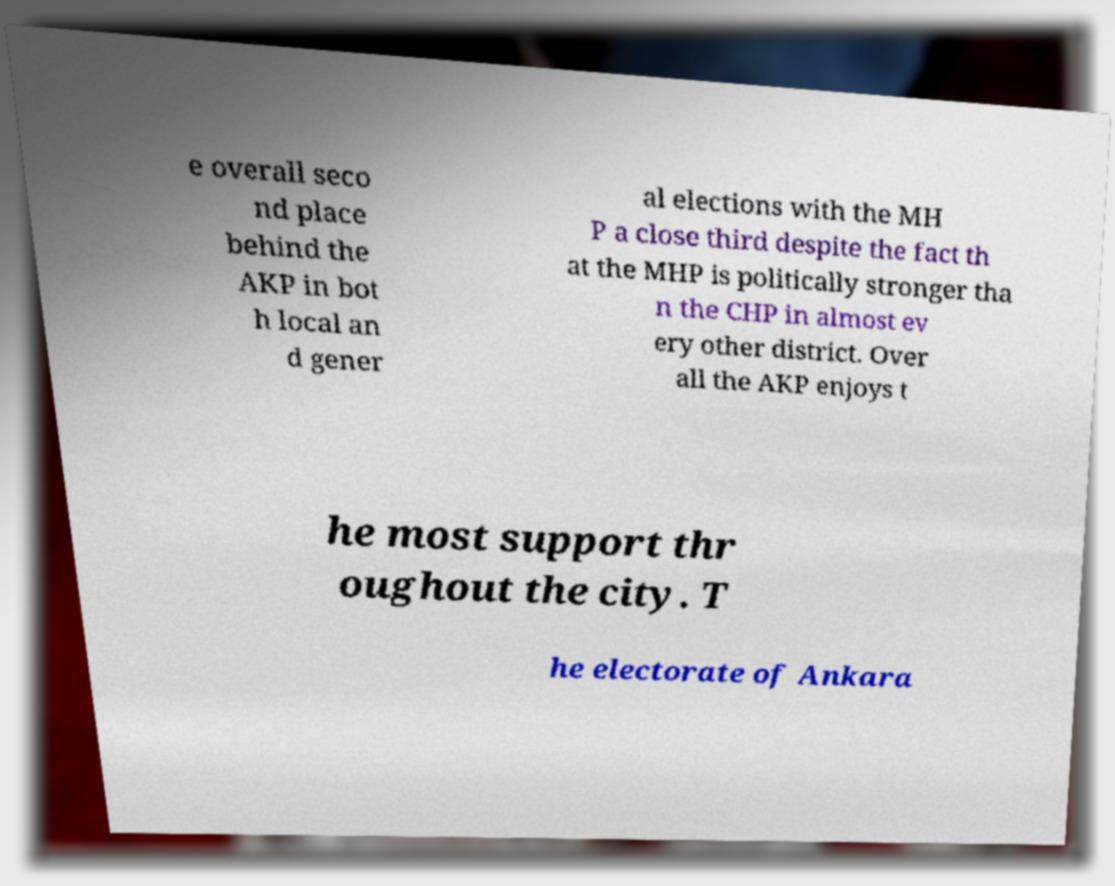There's text embedded in this image that I need extracted. Can you transcribe it verbatim? e overall seco nd place behind the AKP in bot h local an d gener al elections with the MH P a close third despite the fact th at the MHP is politically stronger tha n the CHP in almost ev ery other district. Over all the AKP enjoys t he most support thr oughout the city. T he electorate of Ankara 